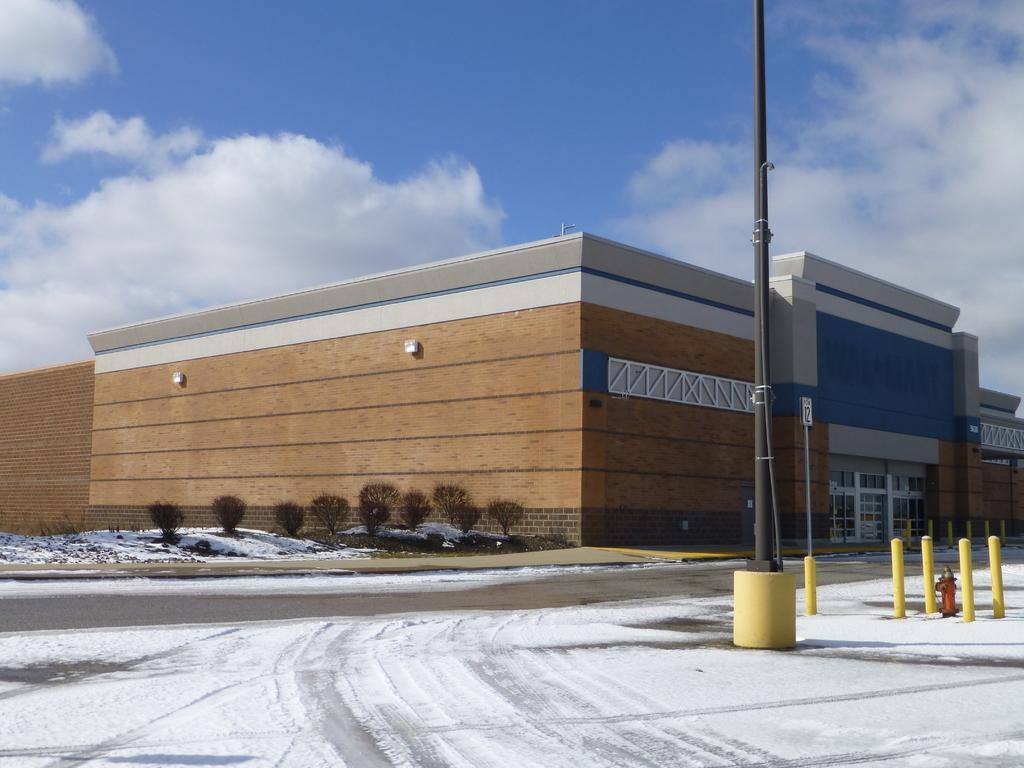Can you describe this image briefly? In this image we can see building, pole, trees, road, snow. In the background we can see sky and clouds. 